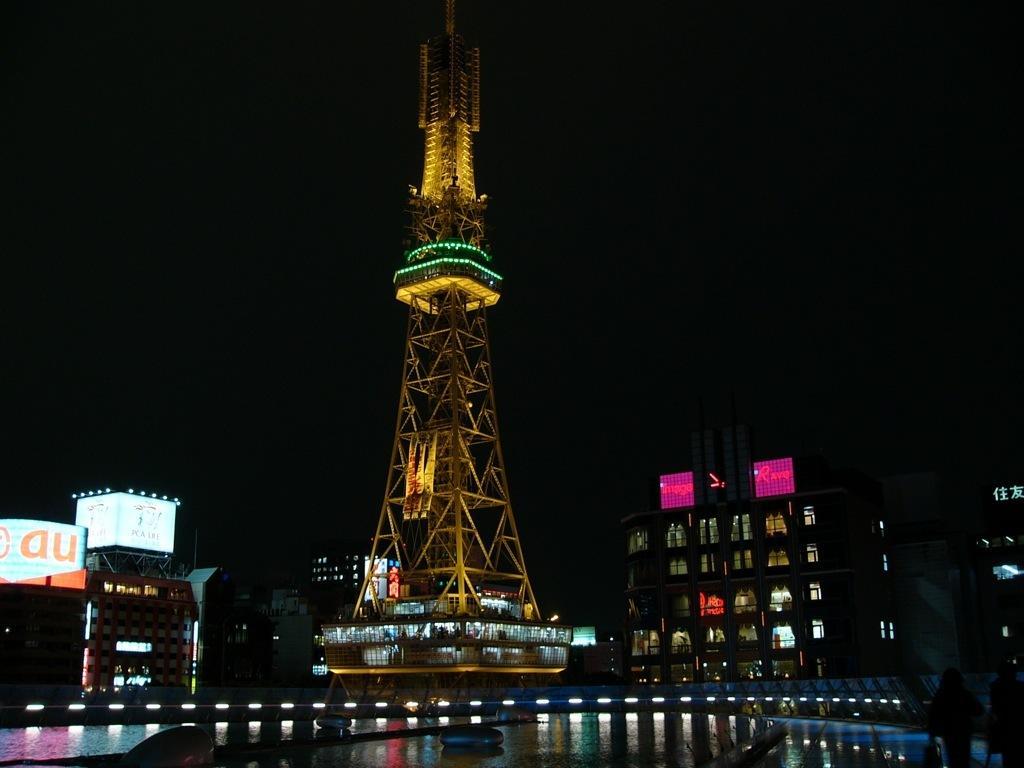Can you describe this image briefly? In this picture there is yellow color iron tower. Beside there are some building. In the front bottom side there are some spot lights and a water pound. 